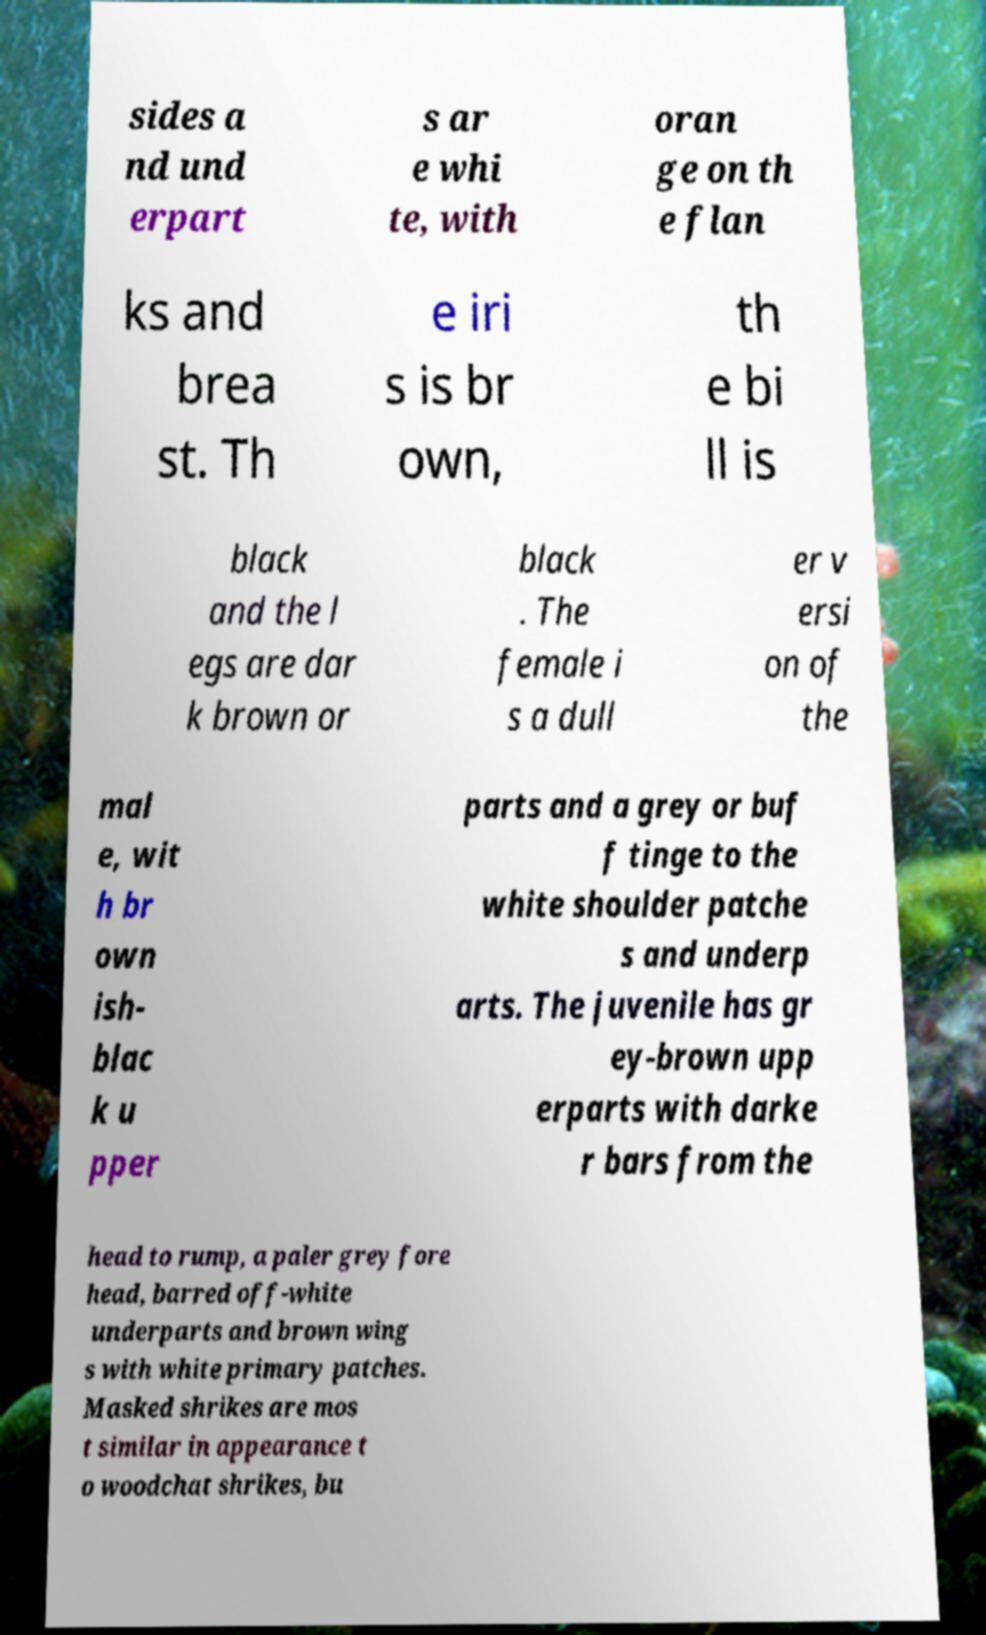Could you assist in decoding the text presented in this image and type it out clearly? sides a nd und erpart s ar e whi te, with oran ge on th e flan ks and brea st. Th e iri s is br own, th e bi ll is black and the l egs are dar k brown or black . The female i s a dull er v ersi on of the mal e, wit h br own ish- blac k u pper parts and a grey or buf f tinge to the white shoulder patche s and underp arts. The juvenile has gr ey-brown upp erparts with darke r bars from the head to rump, a paler grey fore head, barred off-white underparts and brown wing s with white primary patches. Masked shrikes are mos t similar in appearance t o woodchat shrikes, bu 